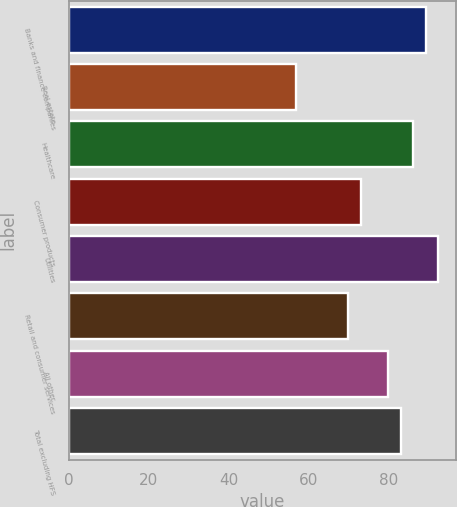<chart> <loc_0><loc_0><loc_500><loc_500><bar_chart><fcel>Banks and finance companies<fcel>Real estate<fcel>Healthcare<fcel>Consumer products<fcel>Utilities<fcel>Retail and consumer services<fcel>All other<fcel>Total excluding HFS<nl><fcel>89.3<fcel>57<fcel>86.2<fcel>73.1<fcel>92.4<fcel>70<fcel>80<fcel>83.1<nl></chart> 